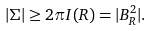<formula> <loc_0><loc_0><loc_500><loc_500>| \Sigma | \geq 2 \pi I ( R ) = | B ^ { 2 } _ { R } | .</formula> 